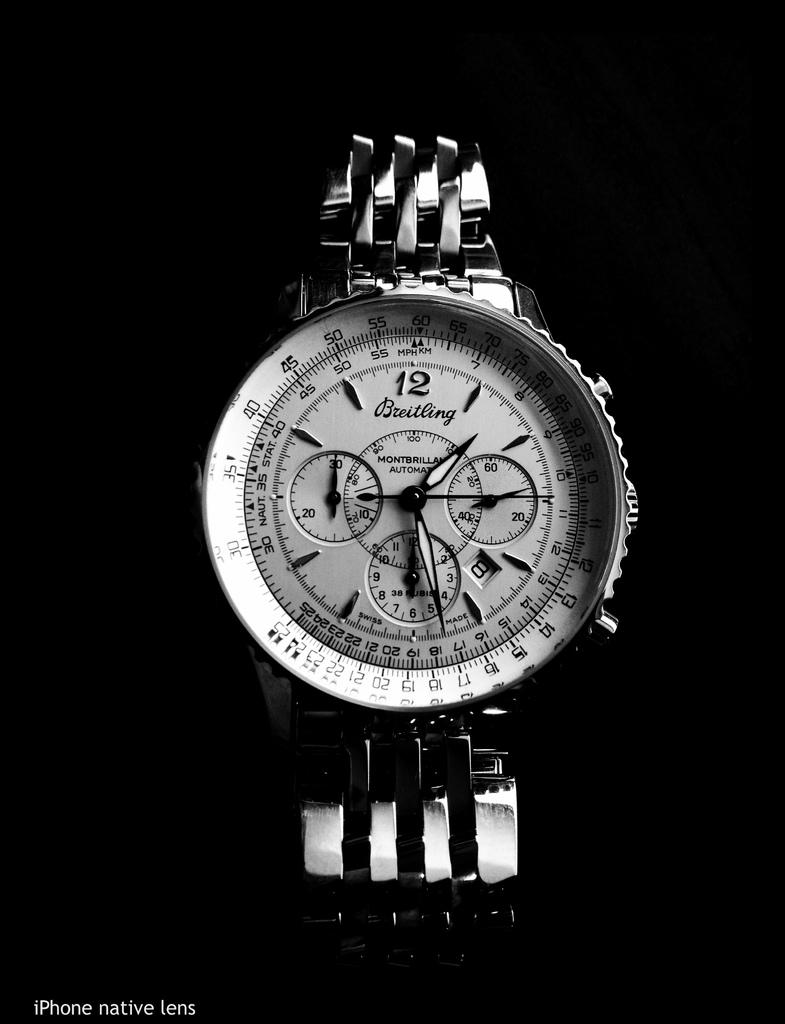<image>
Describe the image concisely. A Breitling brand of wristwatch with multiple gauges is shown in black and white. 